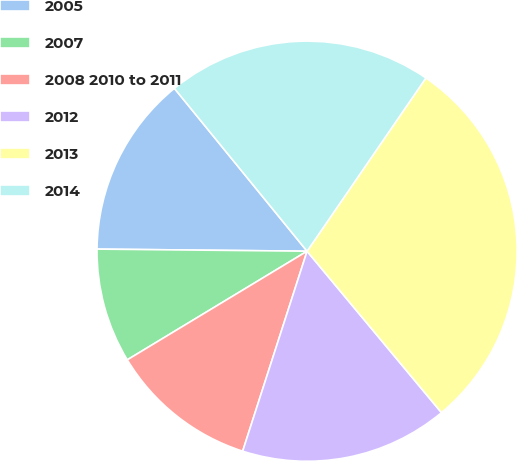Convert chart to OTSL. <chart><loc_0><loc_0><loc_500><loc_500><pie_chart><fcel>2005<fcel>2007<fcel>2008 2010 to 2011<fcel>2012<fcel>2013<fcel>2014<nl><fcel>13.96%<fcel>8.81%<fcel>11.39%<fcel>16.01%<fcel>29.38%<fcel>20.45%<nl></chart> 